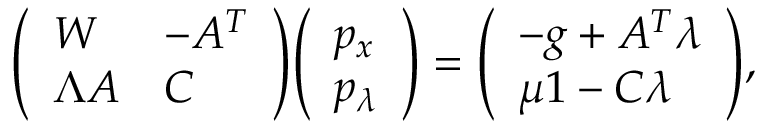Convert formula to latex. <formula><loc_0><loc_0><loc_500><loc_500>{ \left ( \begin{array} { l l } { W } & { - A ^ { T } } \\ { \Lambda A } & { C } \end{array} \right ) } { \left ( \begin{array} { l } { p _ { x } } \\ { p _ { \lambda } } \end{array} \right ) } = { \left ( \begin{array} { l } { - g + A ^ { T } \lambda } \\ { \mu 1 - C \lambda } \end{array} \right ) } ,</formula> 